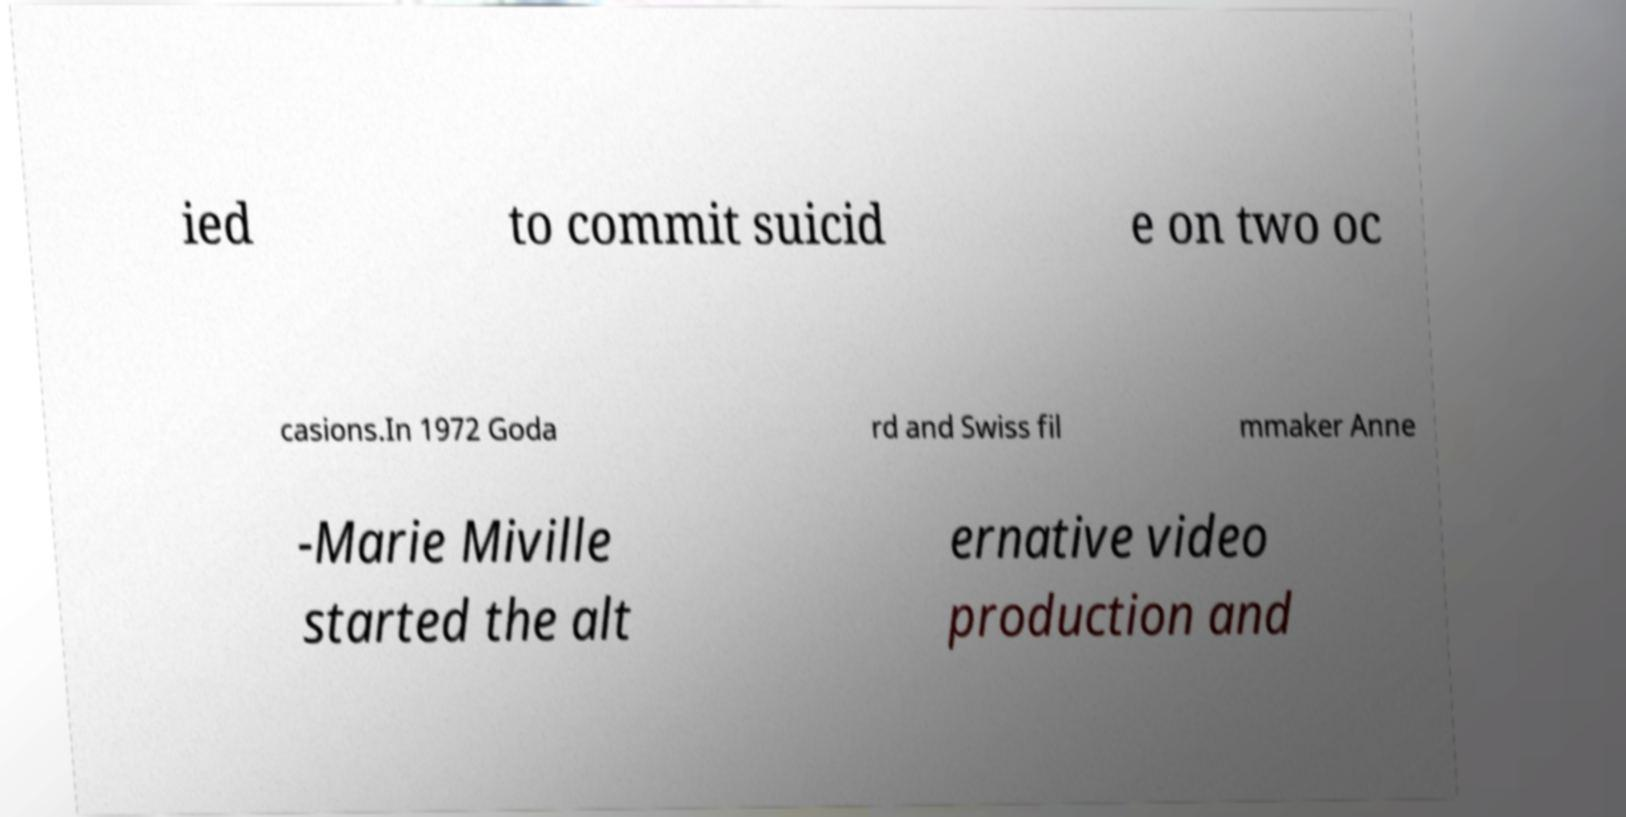There's text embedded in this image that I need extracted. Can you transcribe it verbatim? ied to commit suicid e on two oc casions.In 1972 Goda rd and Swiss fil mmaker Anne -Marie Miville started the alt ernative video production and 